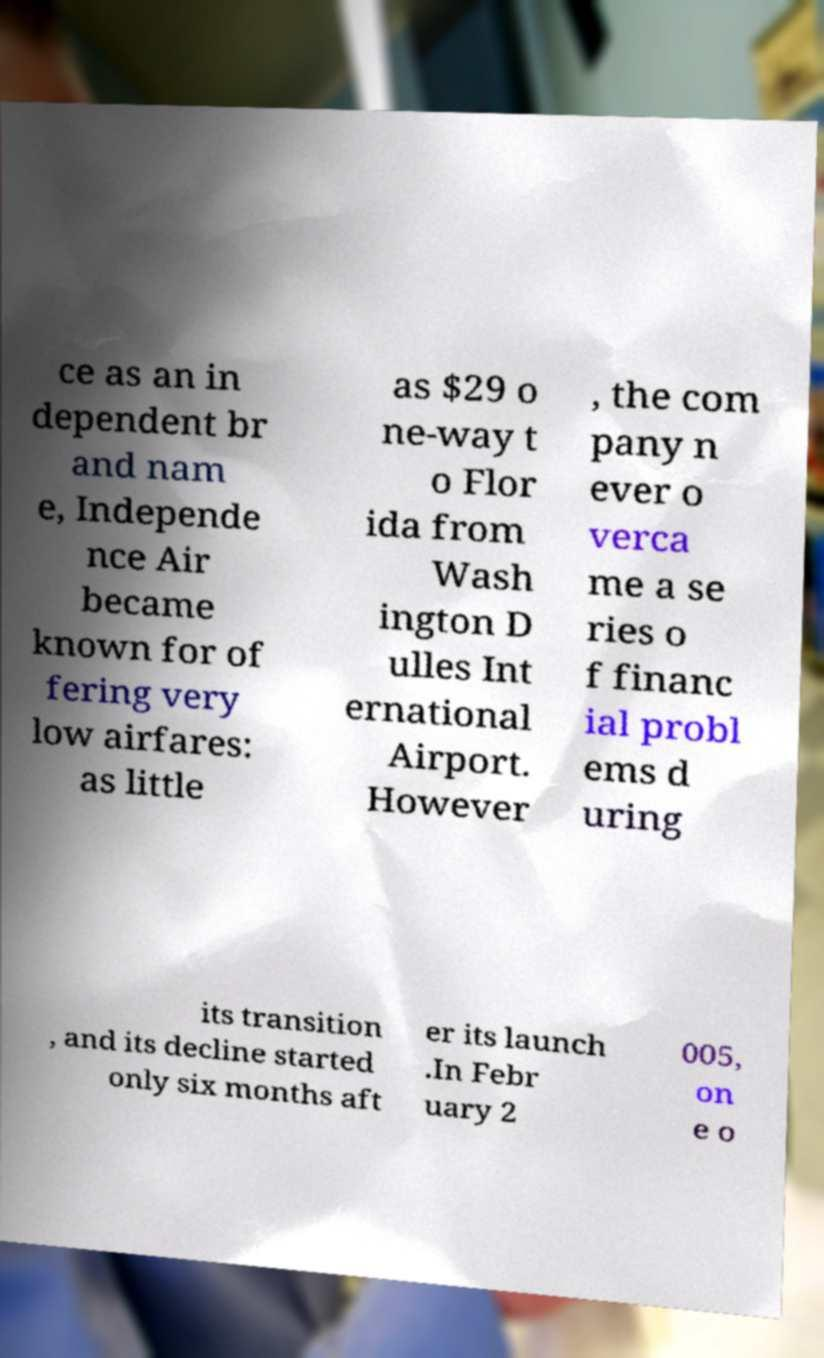I need the written content from this picture converted into text. Can you do that? ce as an in dependent br and nam e, Independe nce Air became known for of fering very low airfares: as little as $29 o ne-way t o Flor ida from Wash ington D ulles Int ernational Airport. However , the com pany n ever o verca me a se ries o f financ ial probl ems d uring its transition , and its decline started only six months aft er its launch .In Febr uary 2 005, on e o 